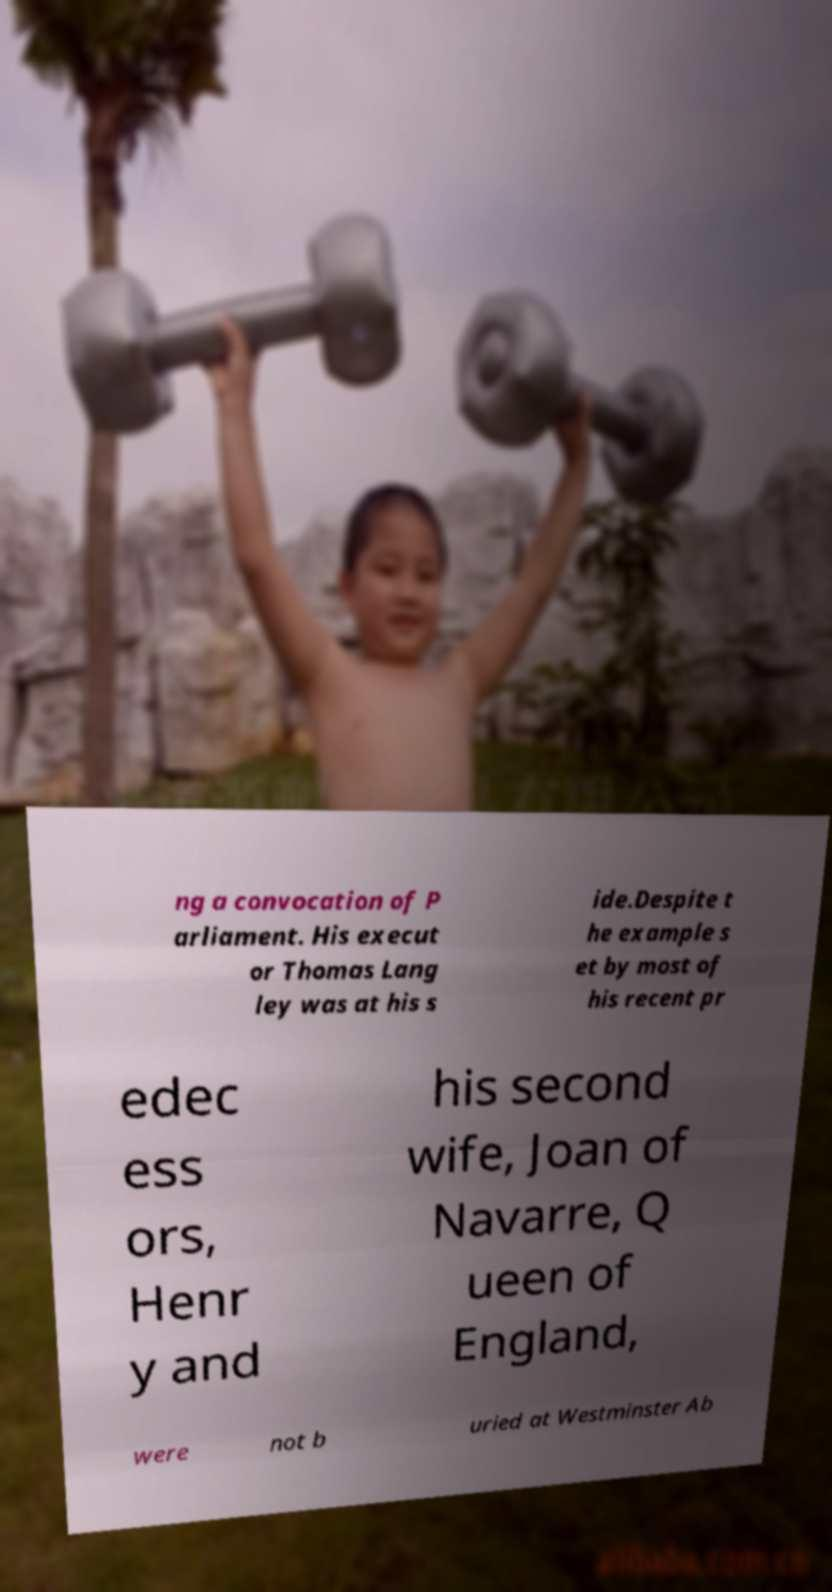I need the written content from this picture converted into text. Can you do that? ng a convocation of P arliament. His execut or Thomas Lang ley was at his s ide.Despite t he example s et by most of his recent pr edec ess ors, Henr y and his second wife, Joan of Navarre, Q ueen of England, were not b uried at Westminster Ab 